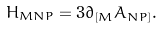Convert formula to latex. <formula><loc_0><loc_0><loc_500><loc_500>H _ { M N P } = 3 \partial _ { [ M } A _ { N P ] } .</formula> 